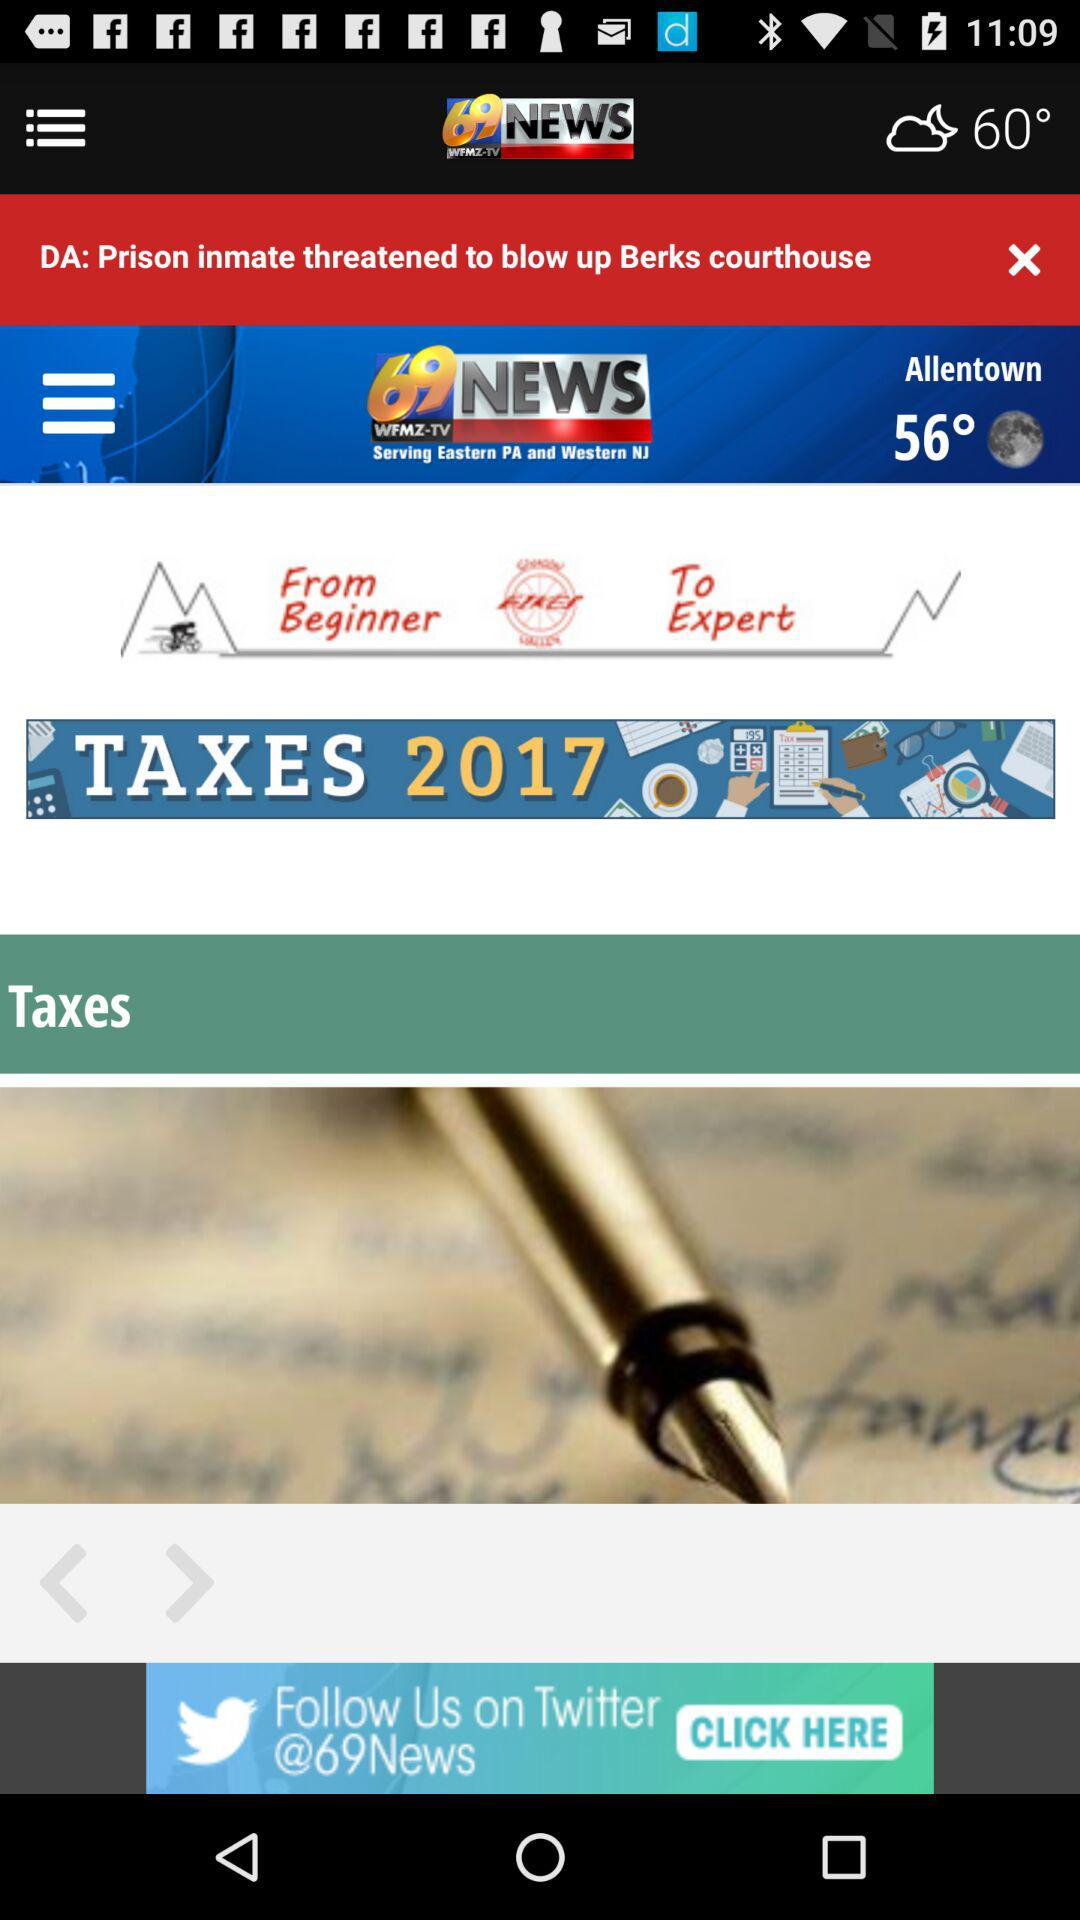What is the temperature in Allentown? The temperature in Allentown is 56°. 